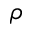Convert formula to latex. <formula><loc_0><loc_0><loc_500><loc_500>\rho</formula> 